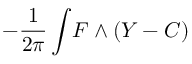Convert formula to latex. <formula><loc_0><loc_0><loc_500><loc_500>- { \frac { 1 } { 2 \pi } } \int \, F \wedge ( Y - C )</formula> 